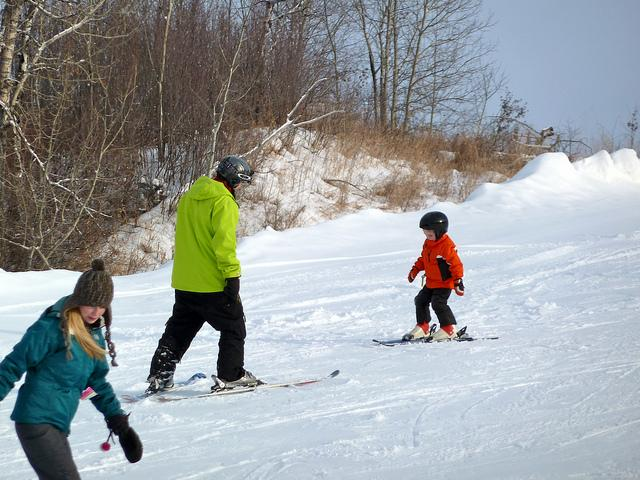The number of people here is called what?

Choices:
A) dozen
B) quartet
C) quintet
D) trio trio 